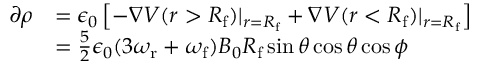<formula> <loc_0><loc_0><loc_500><loc_500>\begin{array} { r l } { \partial \rho } & { = \epsilon _ { 0 } \left [ - \nabla V ( r > R _ { f } ) | _ { r = R _ { f } } + \nabla V ( r < R _ { f } ) | _ { r = R _ { f } } \right ] } \\ & { = \frac { 5 } { 2 } \epsilon _ { 0 } ( 3 \omega _ { r } + \omega _ { f } ) B _ { 0 } R _ { f } \sin \theta \cos \theta \cos \phi } \end{array}</formula> 